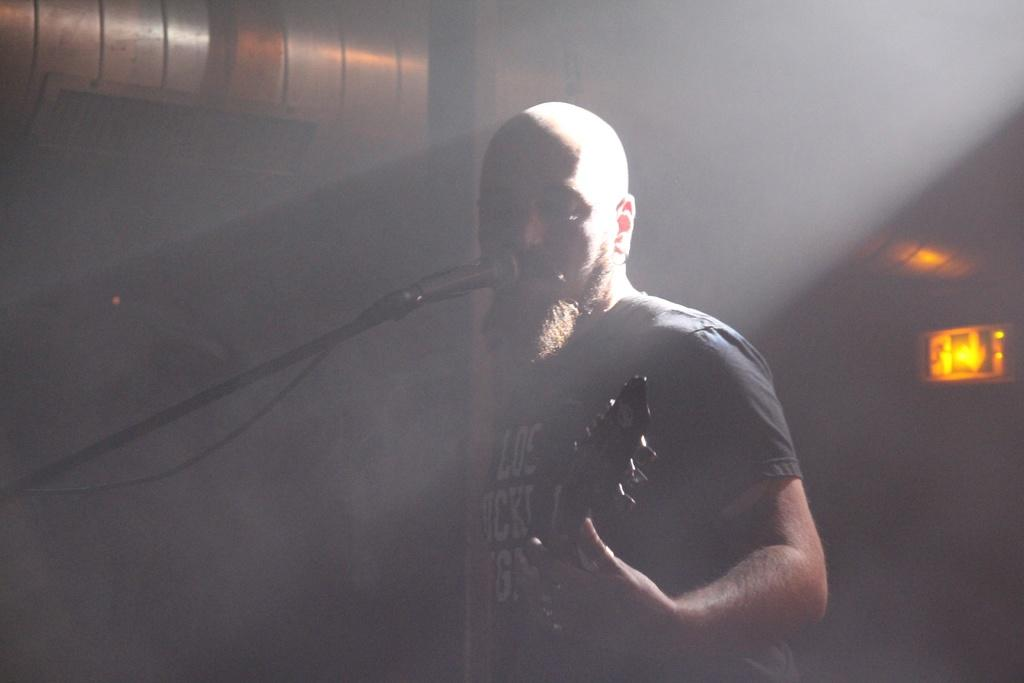What is the main subject of the image? There is a person standing in the center of the image. What is the person holding in the image? The person is holding a guitar. What object is in front of the person? There is a microphone in front of the person. What can be seen in the background of the image? There is a wall and a sign board in the background of the image. What type of door can be seen in the image? There is no door present in the image. Can you describe the picture hanging on the wall in the image? There is no picture hanging on the wall in the image. 